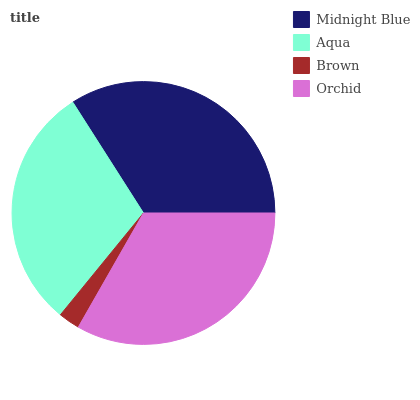Is Brown the minimum?
Answer yes or no. Yes. Is Midnight Blue the maximum?
Answer yes or no. Yes. Is Aqua the minimum?
Answer yes or no. No. Is Aqua the maximum?
Answer yes or no. No. Is Midnight Blue greater than Aqua?
Answer yes or no. Yes. Is Aqua less than Midnight Blue?
Answer yes or no. Yes. Is Aqua greater than Midnight Blue?
Answer yes or no. No. Is Midnight Blue less than Aqua?
Answer yes or no. No. Is Orchid the high median?
Answer yes or no. Yes. Is Aqua the low median?
Answer yes or no. Yes. Is Midnight Blue the high median?
Answer yes or no. No. Is Brown the low median?
Answer yes or no. No. 